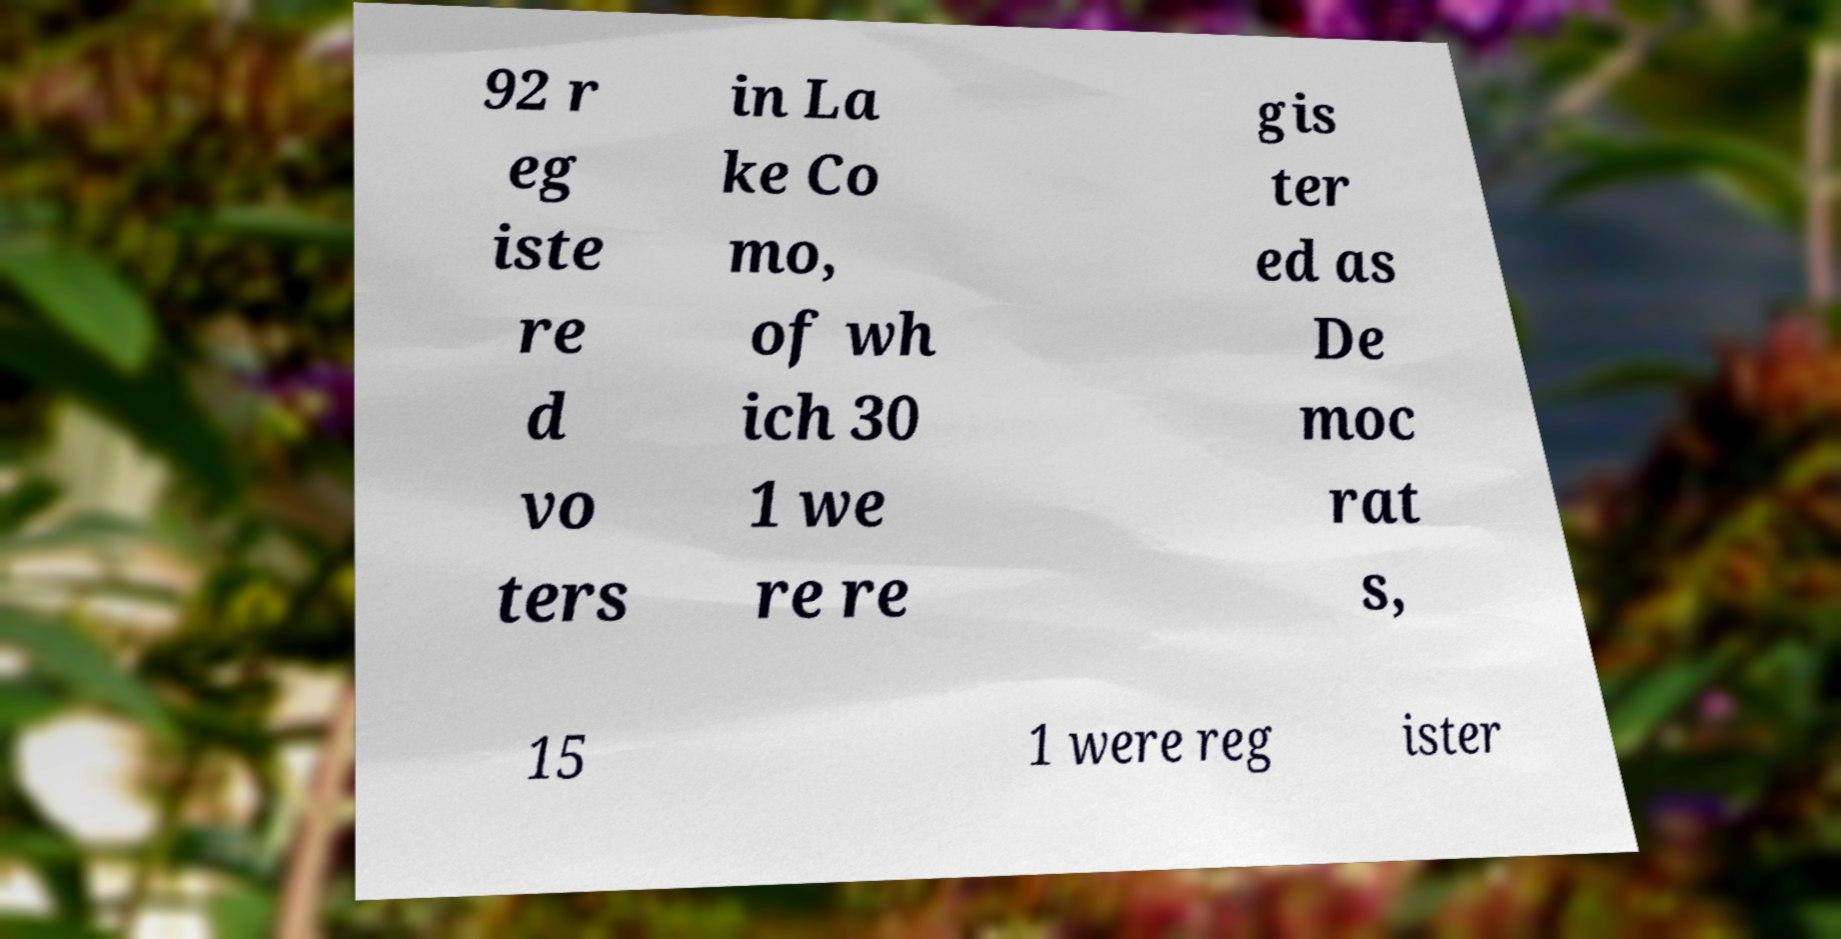Could you extract and type out the text from this image? 92 r eg iste re d vo ters in La ke Co mo, of wh ich 30 1 we re re gis ter ed as De moc rat s, 15 1 were reg ister 